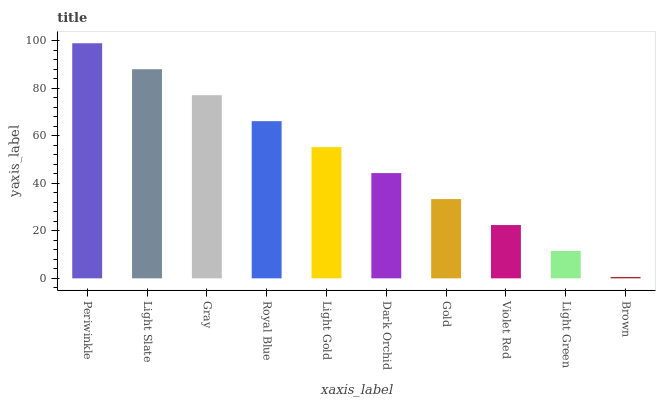Is Brown the minimum?
Answer yes or no. Yes. Is Periwinkle the maximum?
Answer yes or no. Yes. Is Light Slate the minimum?
Answer yes or no. No. Is Light Slate the maximum?
Answer yes or no. No. Is Periwinkle greater than Light Slate?
Answer yes or no. Yes. Is Light Slate less than Periwinkle?
Answer yes or no. Yes. Is Light Slate greater than Periwinkle?
Answer yes or no. No. Is Periwinkle less than Light Slate?
Answer yes or no. No. Is Light Gold the high median?
Answer yes or no. Yes. Is Dark Orchid the low median?
Answer yes or no. Yes. Is Violet Red the high median?
Answer yes or no. No. Is Brown the low median?
Answer yes or no. No. 